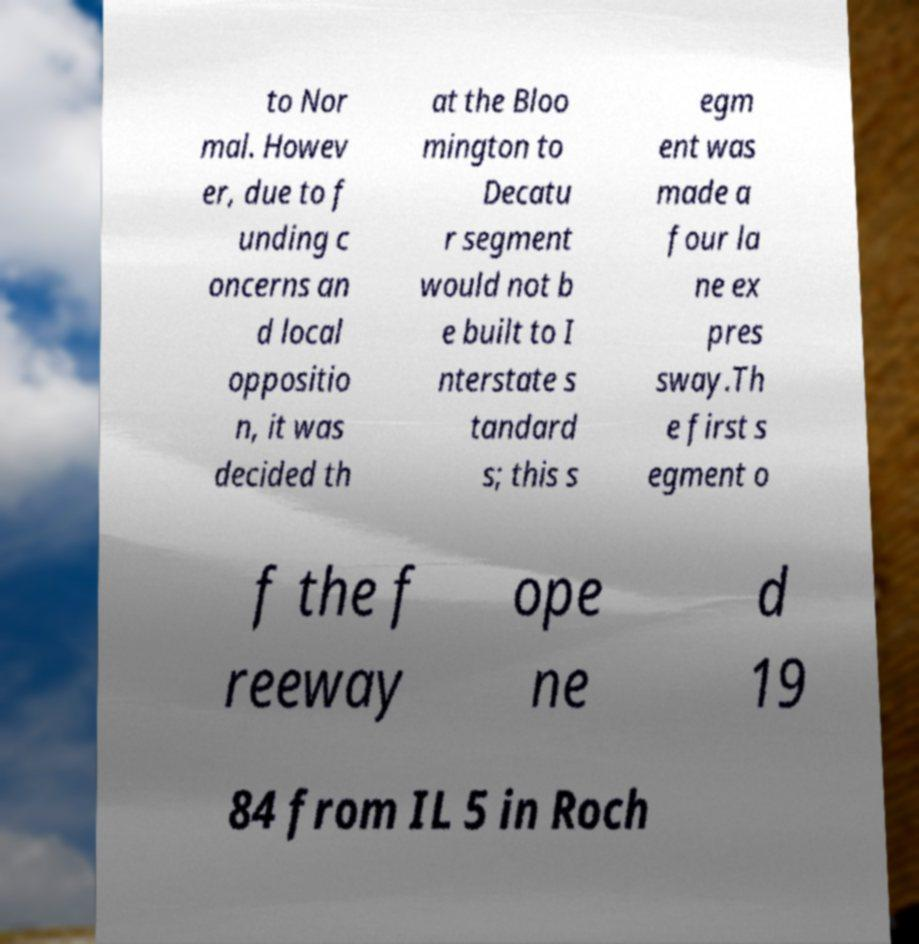Please read and relay the text visible in this image. What does it say? to Nor mal. Howev er, due to f unding c oncerns an d local oppositio n, it was decided th at the Bloo mington to Decatu r segment would not b e built to I nterstate s tandard s; this s egm ent was made a four la ne ex pres sway.Th e first s egment o f the f reeway ope ne d 19 84 from IL 5 in Roch 